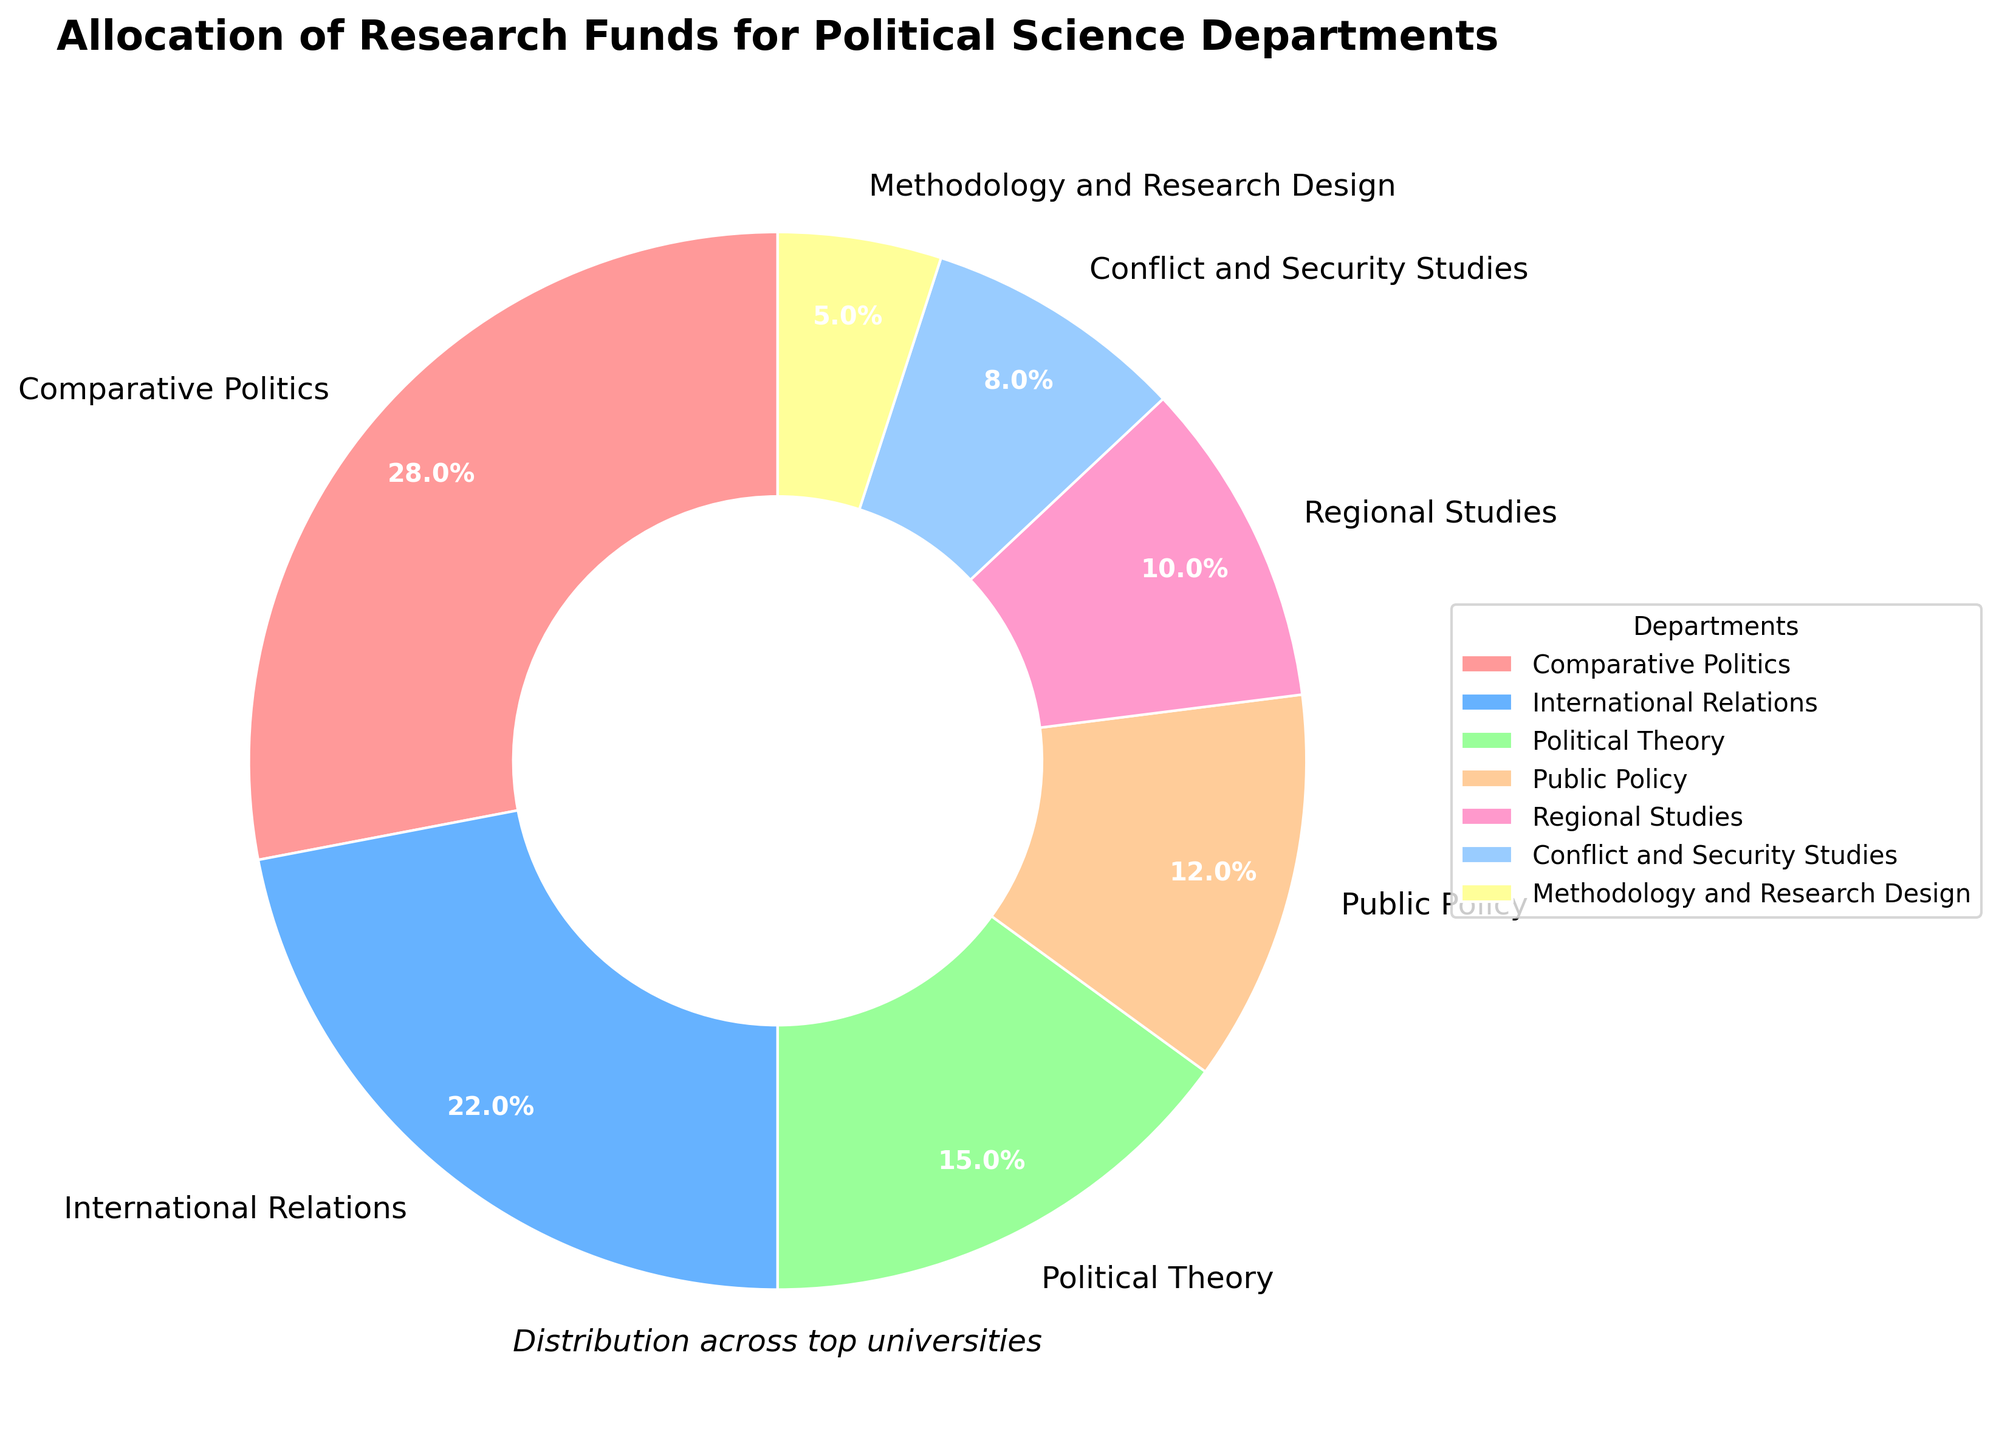What's the combined funding percentage for Comparative Politics and International Relations? The figure shows that Comparative Politics has 28% and International Relations has 22%. Summing these two values gives us 28% + 22% = 50%
Answer: 50% Which department has a larger allocation: Political Theory or Public Policy? The figure indicates that Political Theory has 15% and Public Policy has 12%. Since 15% is greater than 12%, Political Theory has a larger allocation.
Answer: Political Theory What is the difference in allocation between Comparative Politics and Methodology and Research Design? Comparative Politics has 28% allocation, and Methodology and Research Design has 5%. The difference is calculated as 28% - 5% = 23%
Answer: 23% What percentage of funding is allocated to departments with less than 10% each? The figure shows three departments with less than 10%: Regional Studies (10%), Conflict and Security Studies (8%), and Methodology and Research Design (5%). Summing these gives us 10% + 8% + 5% = 23%
Answer: 23% Which department has the smallest slice in the pie chart? The department with the smallest slice in the pie chart is Methodology and Research Design, with 5% allocation.
Answer: Methodology and Research Design If Public Policy and Regional Studies had their percentages reversed, what would Public Policy's new allocation be? Public Policy currently has 12%, and Regional Studies has 10%. If reversed, Public Policy would have 10%.
Answer: 10% Do the combined allocations of Comparative Politics and Conflict and Security Studies exceed 1/3 of the total funding? Comparative Politics has 28%, and Conflict and Security Studies has 8%. Their combined allocation is 28% + 8% = 36%. Since 1/3 (or approximately 33.3%) is less than 36%, they do exceed 1/3 of the total funding.
Answer: Yes What color is used to represent International Relations in the pie chart? According to the figure, International Relations is represented by the second color listed, which is a shade of blue.
Answer: Blue Are the total allocations for Political Theory and Public Policy together greater than that for Comparative Politics alone? Political Theory has 15% and Public Policy has 12%. Together their allocation is 15% + 12% = 27%. Comparative Politics alone has 28%. Since 27% is less than 28%, their combined allocation is not greater.
Answer: No How much more funding does Comparative Politics receive compared to Conflict and Security Studies? Comparative Politics receives 28%, and Conflict and Security Studies receives 8%. The difference is 28% - 8% = 20%
Answer: 20% 